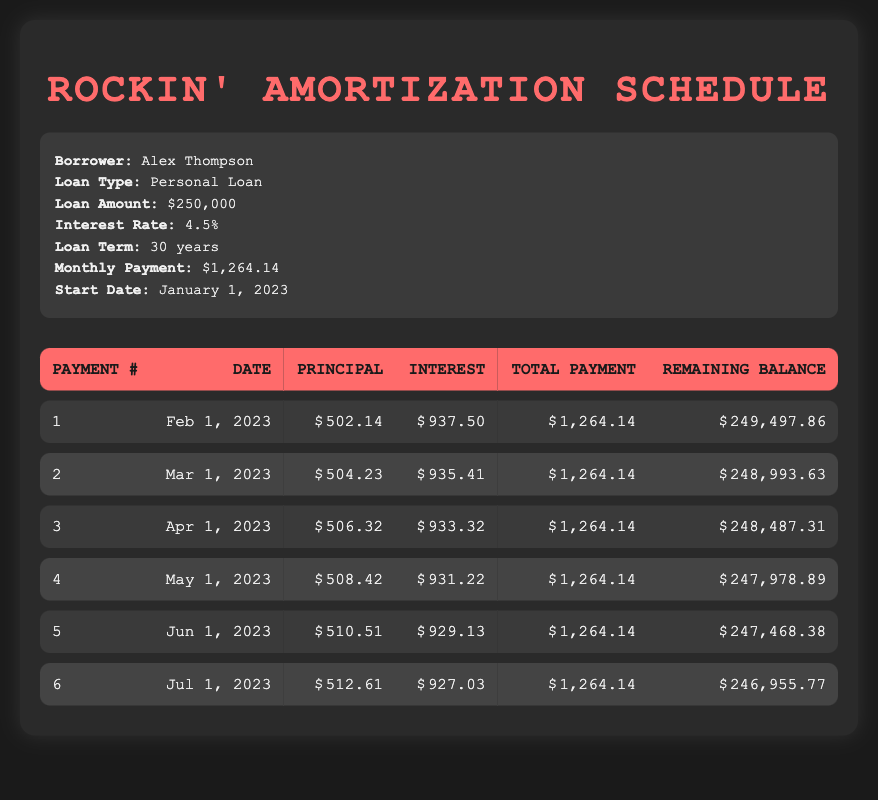What is the monthly payment amount for this loan? The monthly payment amount for this loan is listed in the loan details section of the table. It is specified as $1,264.14.
Answer: 1,264.14 How much is the total principal paid in the first payment? The principal payment for the first payment is found directly in the amortization schedule, where it states $502.14.
Answer: 502.14 What is the remaining balance after the second payment? The remaining balance after the second payment is specified in the amortization schedule. It shows that after the second payment, the remaining balance is $248,993.63.
Answer: 248,993.63 How much interest is paid in the fifth payment? The interest payment for the fifth payment can be found in the fifth row of the schedule, which indicates that the interest payment is $929.13.
Answer: 929.13 What is the total principal paid over the first six payments? To find the total principal paid, we add up the principal payments for the first six payments: 502.14 + 504.23 + 506.32 + 508.42 + 510.51 + 512.61 = 2,543.23.
Answer: 2,543.23 Is the interest payment decreasing with each payment? By looking at the interest payments from the schedule, we see that the interest payments are indeed decreasing: $937.50, $935.41, $933.32, $931.22, $929.13, and $927.03. Therefore, the statement is true.
Answer: Yes What is the average monthly principal payment for the first six payments? To find the average monthly principal payment, we total the principal payments: 502.14 + 504.23 + 506.32 + 508.42 + 510.51 + 512.61 = 2,543.23. Then we divide by the number of payments (6): 2,543.23 / 6 ≈ 423.87.
Answer: 423.87 What is the total amount paid in interest after the first three payments? The interest payments for the first three payments are: $937.50 + $935.41 + $933.32 = $2,806.23. Thus, the total interest paid after the first three payments is $2,806.23.
Answer: 2,806.23 How much does the remaining balance decrease after the first payment? The remaining balance before the first payment is $250,000. After the first payment, it is $249,497.86. The decrease is calculated as $250,000 - $249,497.86 = $502.14.
Answer: 502.14 